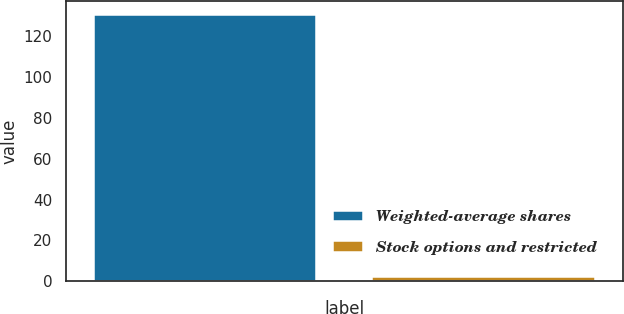<chart> <loc_0><loc_0><loc_500><loc_500><bar_chart><fcel>Weighted-average shares<fcel>Stock options and restricted<nl><fcel>130.57<fcel>2.2<nl></chart> 